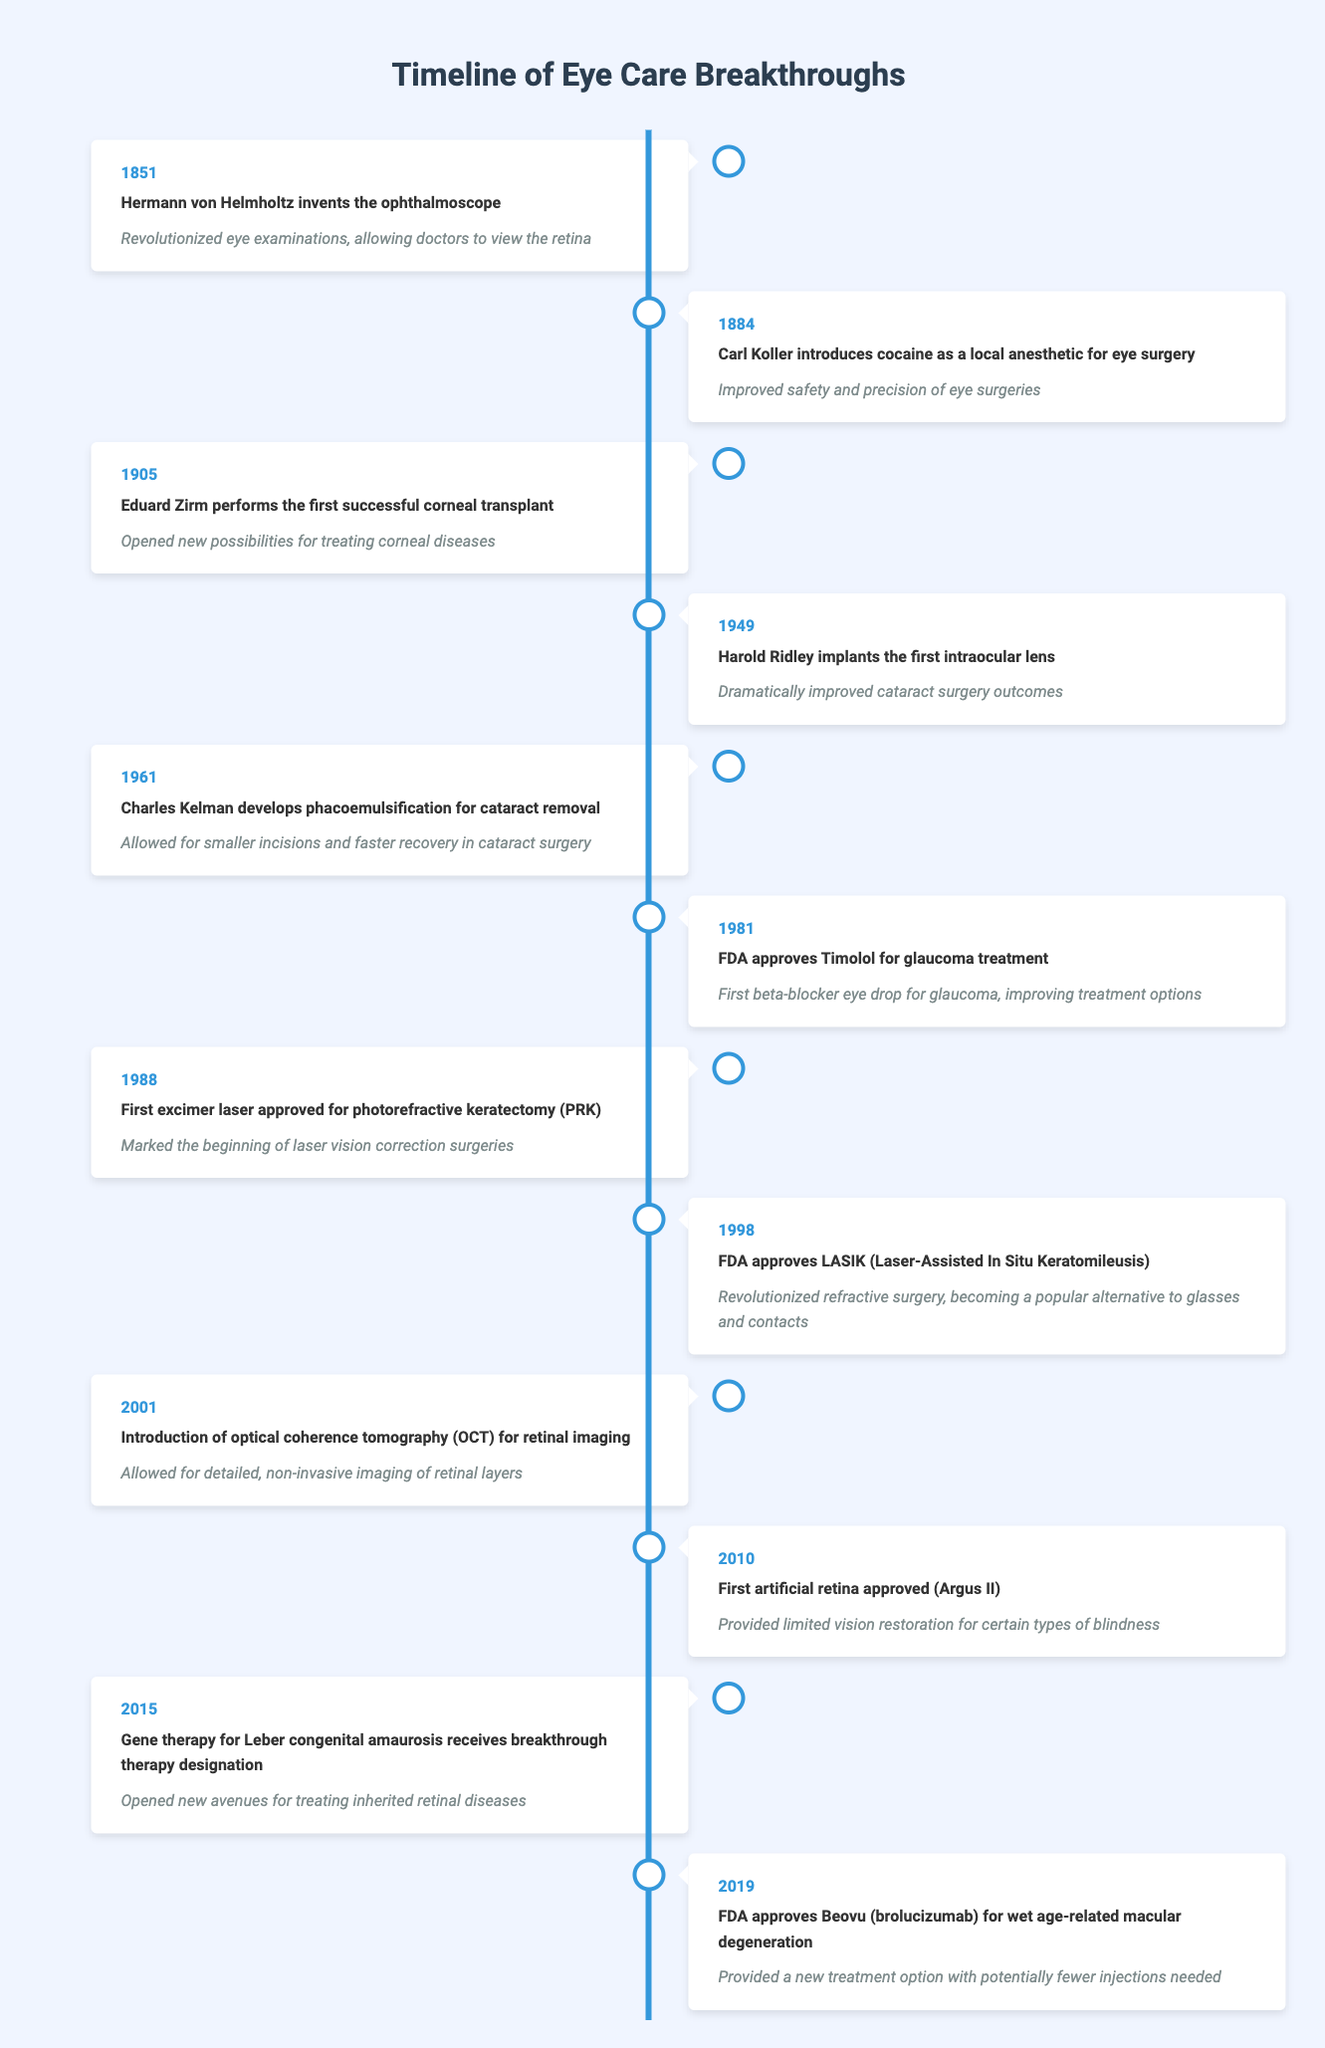What year did Hermann von Helmholtz invent the ophthalmoscope? The table indicates that Hermann von Helmholtz invented the ophthalmoscope in the year 1851.
Answer: 1851 Which breakthrough provided improved safety and precision in eye surgeries? The table shows that Carl Koller introduced cocaine as a local anesthetic for eye surgery in 1884, which improved safety and precision.
Answer: Cocaine as a local anesthetic What was the first successful corneal transplant performed? According to the timeline, Eduard Zirm performed the first successful corneal transplant in 1905.
Answer: Eduard Zirm How many years passed between the introduction of optical coherence tomography (OCT) and the approval of the first artificial retina? The introduction of OCT occurred in 2001 and the first artificial retina was approved in 2010, which is a difference of 9 years.
Answer: 9 years Did the first excimer laser get approved before or after FDA approval of LASIK? The first excimer laser was approved in 1988 and LASIK was approved in 1998, indicating the excimer laser was approved before LASIK.
Answer: Before Which treatment for wet age-related macular degeneration was approved in 2019? The timeline states that Beovu (brolucizumab) was approved for wet age-related macular degeneration in 2019.
Answer: Beovu (brolucizumab) What has been the trend regarding eye disease treatments from 1851 to 2019 based on significant breakthroughs? The timeline shows a continuous advancement in eye disease treatments, starting with the ophthalmoscope in 1851 to more complex interventions like gene therapy and artificial retinas by 2019, indicating a positive trend in innovation.
Answer: Continuous advancement What was the significance of the first intraocular lens implanted in 1949? The first intraocular lens implantation by Harold Ridley significantly improved cataract surgery outcomes, as recorded in the table.
Answer: Dramatically improved cataract surgery outcomes Which years saw significant developments in glaucoma treatments based on FDA approvals? The table lists FDA approvals for Timolol in 1981, which marked the development of new glaucoma treatments, showing 1981 as a significant year for glaucoma advancements.
Answer: 1981 